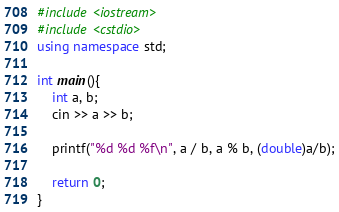<code> <loc_0><loc_0><loc_500><loc_500><_C++_>#include <iostream>
#include <cstdio>
using namespace std;

int main(){
	int a, b;
	cin >> a >> b;
	
	printf("%d %d %f\n", a / b, a % b, (double)a/b);
	
	return 0;
}
</code> 